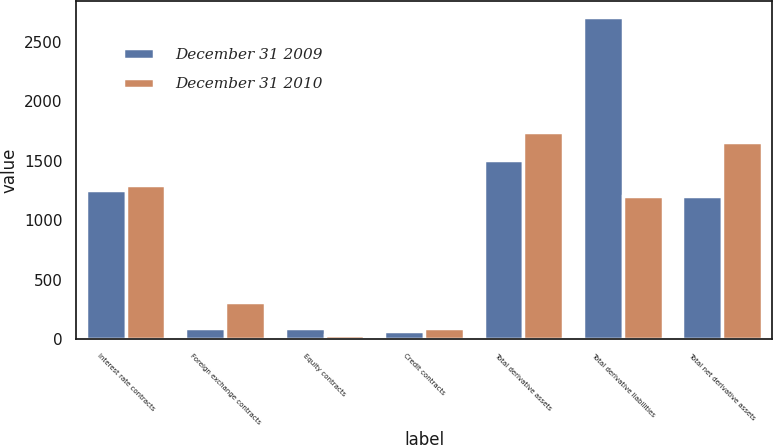Convert chart to OTSL. <chart><loc_0><loc_0><loc_500><loc_500><stacked_bar_chart><ecel><fcel>Interest rate contracts<fcel>Foreign exchange contracts<fcel>Equity contracts<fcel>Credit contracts<fcel>Total derivative assets<fcel>Total derivative liabilities<fcel>Total net derivative assets<nl><fcel>December 31 2009<fcel>1251<fcel>92<fcel>96<fcel>65<fcel>1504<fcel>2708<fcel>1204<nl><fcel>December 31 2010<fcel>1297<fcel>309<fcel>36<fcel>94<fcel>1736<fcel>1204<fcel>1656<nl></chart> 